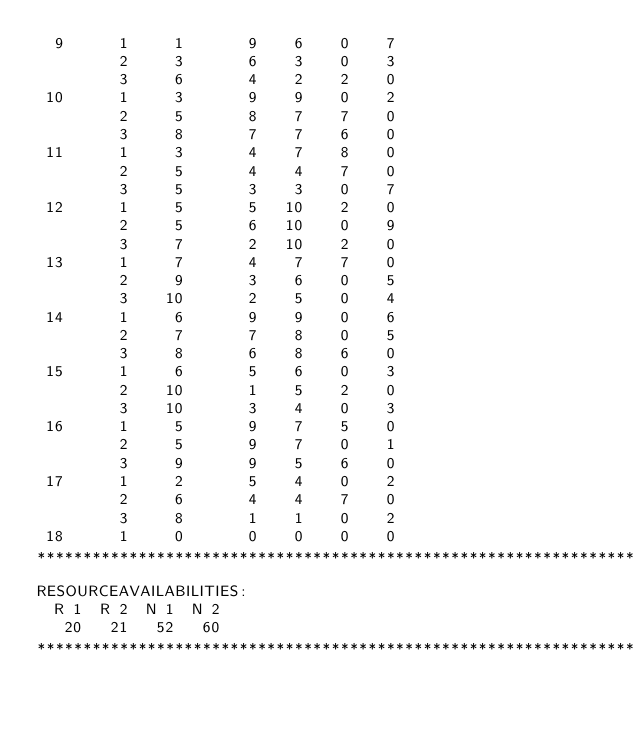<code> <loc_0><loc_0><loc_500><loc_500><_ObjectiveC_>  9      1     1       9    6    0    7
         2     3       6    3    0    3
         3     6       4    2    2    0
 10      1     3       9    9    0    2
         2     5       8    7    7    0
         3     8       7    7    6    0
 11      1     3       4    7    8    0
         2     5       4    4    7    0
         3     5       3    3    0    7
 12      1     5       5   10    2    0
         2     5       6   10    0    9
         3     7       2   10    2    0
 13      1     7       4    7    7    0
         2     9       3    6    0    5
         3    10       2    5    0    4
 14      1     6       9    9    0    6
         2     7       7    8    0    5
         3     8       6    8    6    0
 15      1     6       5    6    0    3
         2    10       1    5    2    0
         3    10       3    4    0    3
 16      1     5       9    7    5    0
         2     5       9    7    0    1
         3     9       9    5    6    0
 17      1     2       5    4    0    2
         2     6       4    4    7    0
         3     8       1    1    0    2
 18      1     0       0    0    0    0
************************************************************************
RESOURCEAVAILABILITIES:
  R 1  R 2  N 1  N 2
   20   21   52   60
************************************************************************
</code> 